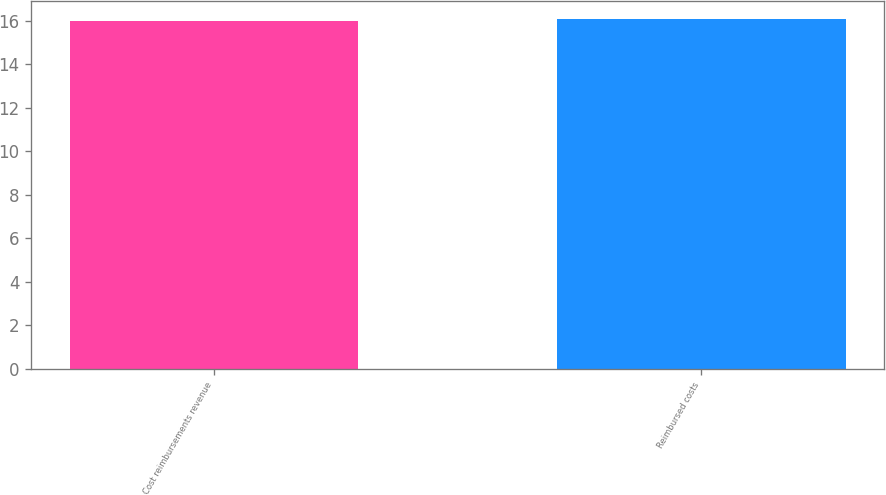Convert chart to OTSL. <chart><loc_0><loc_0><loc_500><loc_500><bar_chart><fcel>Cost reimbursements revenue<fcel>Reimbursed costs<nl><fcel>16<fcel>16.1<nl></chart> 